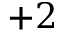Convert formula to latex. <formula><loc_0><loc_0><loc_500><loc_500>{ + 2 }</formula> 